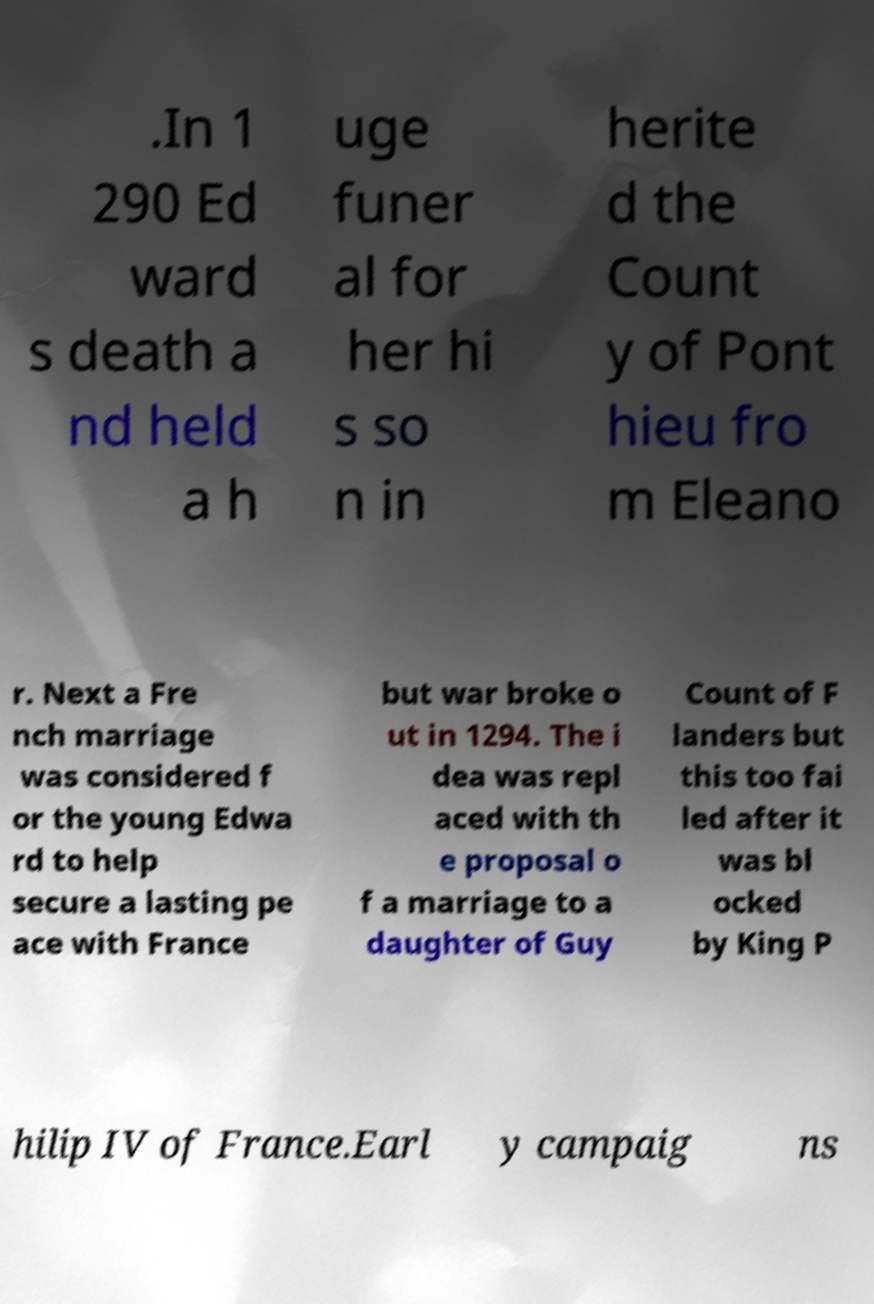There's text embedded in this image that I need extracted. Can you transcribe it verbatim? .In 1 290 Ed ward s death a nd held a h uge funer al for her hi s so n in herite d the Count y of Pont hieu fro m Eleano r. Next a Fre nch marriage was considered f or the young Edwa rd to help secure a lasting pe ace with France but war broke o ut in 1294. The i dea was repl aced with th e proposal o f a marriage to a daughter of Guy Count of F landers but this too fai led after it was bl ocked by King P hilip IV of France.Earl y campaig ns 